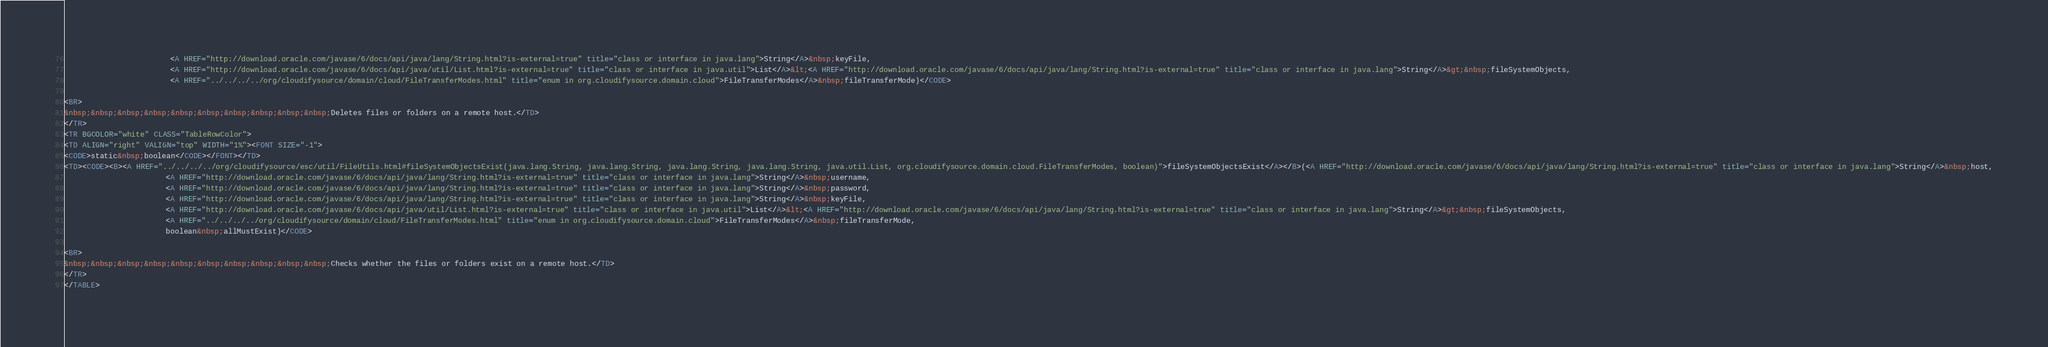Convert code to text. <code><loc_0><loc_0><loc_500><loc_500><_HTML_>                        <A HREF="http://download.oracle.com/javase/6/docs/api/java/lang/String.html?is-external=true" title="class or interface in java.lang">String</A>&nbsp;keyFile,
                        <A HREF="http://download.oracle.com/javase/6/docs/api/java/util/List.html?is-external=true" title="class or interface in java.util">List</A>&lt;<A HREF="http://download.oracle.com/javase/6/docs/api/java/lang/String.html?is-external=true" title="class or interface in java.lang">String</A>&gt;&nbsp;fileSystemObjects,
                        <A HREF="../../../../org/cloudifysource/domain/cloud/FileTransferModes.html" title="enum in org.cloudifysource.domain.cloud">FileTransferModes</A>&nbsp;fileTransferMode)</CODE>

<BR>
&nbsp;&nbsp;&nbsp;&nbsp;&nbsp;&nbsp;&nbsp;&nbsp;&nbsp;&nbsp;Deletes files or folders on a remote host.</TD>
</TR>
<TR BGCOLOR="white" CLASS="TableRowColor">
<TD ALIGN="right" VALIGN="top" WIDTH="1%"><FONT SIZE="-1">
<CODE>static&nbsp;boolean</CODE></FONT></TD>
<TD><CODE><B><A HREF="../../../../org/cloudifysource/esc/util/FileUtils.html#fileSystemObjectsExist(java.lang.String, java.lang.String, java.lang.String, java.lang.String, java.util.List, org.cloudifysource.domain.cloud.FileTransferModes, boolean)">fileSystemObjectsExist</A></B>(<A HREF="http://download.oracle.com/javase/6/docs/api/java/lang/String.html?is-external=true" title="class or interface in java.lang">String</A>&nbsp;host,
                       <A HREF="http://download.oracle.com/javase/6/docs/api/java/lang/String.html?is-external=true" title="class or interface in java.lang">String</A>&nbsp;username,
                       <A HREF="http://download.oracle.com/javase/6/docs/api/java/lang/String.html?is-external=true" title="class or interface in java.lang">String</A>&nbsp;password,
                       <A HREF="http://download.oracle.com/javase/6/docs/api/java/lang/String.html?is-external=true" title="class or interface in java.lang">String</A>&nbsp;keyFile,
                       <A HREF="http://download.oracle.com/javase/6/docs/api/java/util/List.html?is-external=true" title="class or interface in java.util">List</A>&lt;<A HREF="http://download.oracle.com/javase/6/docs/api/java/lang/String.html?is-external=true" title="class or interface in java.lang">String</A>&gt;&nbsp;fileSystemObjects,
                       <A HREF="../../../../org/cloudifysource/domain/cloud/FileTransferModes.html" title="enum in org.cloudifysource.domain.cloud">FileTransferModes</A>&nbsp;fileTransferMode,
                       boolean&nbsp;allMustExist)</CODE>

<BR>
&nbsp;&nbsp;&nbsp;&nbsp;&nbsp;&nbsp;&nbsp;&nbsp;&nbsp;&nbsp;Checks whether the files or folders exist on a remote host.</TD>
</TR>
</TABLE></code> 